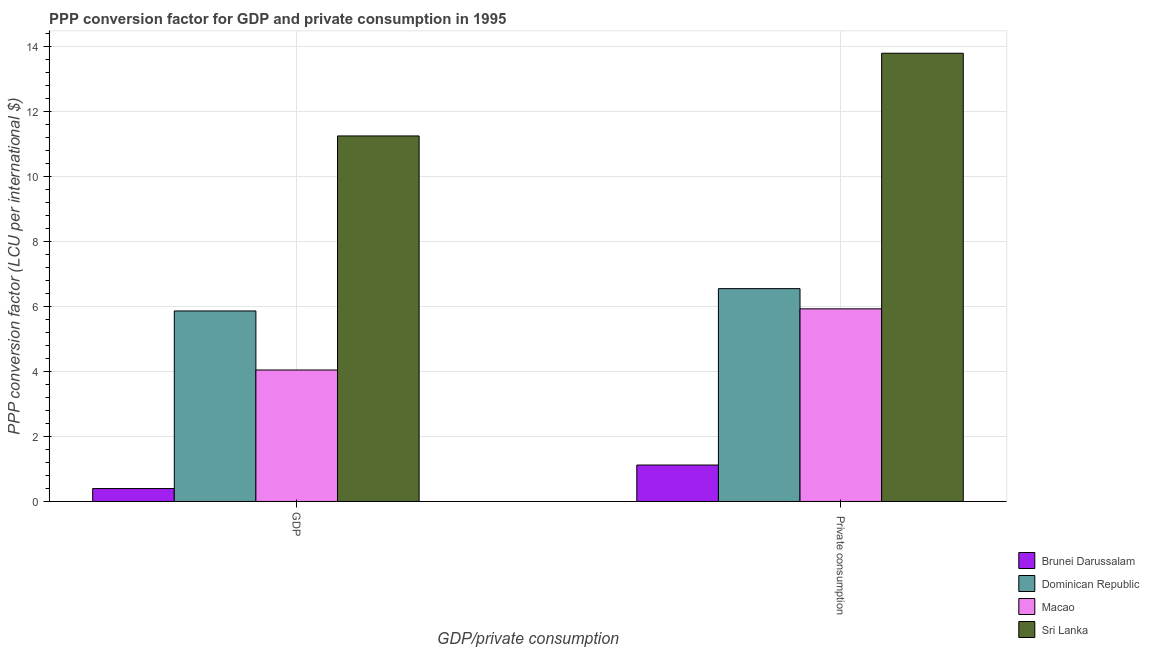How many different coloured bars are there?
Give a very brief answer. 4. How many groups of bars are there?
Your response must be concise. 2. Are the number of bars per tick equal to the number of legend labels?
Ensure brevity in your answer.  Yes. How many bars are there on the 2nd tick from the left?
Keep it short and to the point. 4. How many bars are there on the 1st tick from the right?
Give a very brief answer. 4. What is the label of the 2nd group of bars from the left?
Provide a succinct answer.  Private consumption. What is the ppp conversion factor for private consumption in Macao?
Offer a very short reply. 5.93. Across all countries, what is the maximum ppp conversion factor for gdp?
Offer a terse response. 11.25. Across all countries, what is the minimum ppp conversion factor for private consumption?
Keep it short and to the point. 1.12. In which country was the ppp conversion factor for gdp maximum?
Provide a succinct answer. Sri Lanka. In which country was the ppp conversion factor for private consumption minimum?
Ensure brevity in your answer.  Brunei Darussalam. What is the total ppp conversion factor for gdp in the graph?
Provide a succinct answer. 21.56. What is the difference between the ppp conversion factor for private consumption in Sri Lanka and that in Dominican Republic?
Provide a succinct answer. 7.24. What is the difference between the ppp conversion factor for gdp in Macao and the ppp conversion factor for private consumption in Dominican Republic?
Provide a short and direct response. -2.5. What is the average ppp conversion factor for private consumption per country?
Give a very brief answer. 6.85. What is the difference between the ppp conversion factor for private consumption and ppp conversion factor for gdp in Macao?
Your response must be concise. 1.88. In how many countries, is the ppp conversion factor for gdp greater than 8.4 LCU?
Keep it short and to the point. 1. What is the ratio of the ppp conversion factor for private consumption in Sri Lanka to that in Macao?
Ensure brevity in your answer.  2.33. What does the 1st bar from the left in GDP represents?
Offer a terse response. Brunei Darussalam. What does the 4th bar from the right in  Private consumption represents?
Your answer should be compact. Brunei Darussalam. How many bars are there?
Your answer should be compact. 8. How many countries are there in the graph?
Your response must be concise. 4. How many legend labels are there?
Give a very brief answer. 4. How are the legend labels stacked?
Make the answer very short. Vertical. What is the title of the graph?
Your response must be concise. PPP conversion factor for GDP and private consumption in 1995. What is the label or title of the X-axis?
Offer a terse response. GDP/private consumption. What is the label or title of the Y-axis?
Your answer should be compact. PPP conversion factor (LCU per international $). What is the PPP conversion factor (LCU per international $) in Brunei Darussalam in GDP?
Offer a very short reply. 0.4. What is the PPP conversion factor (LCU per international $) in Dominican Republic in GDP?
Your answer should be very brief. 5.86. What is the PPP conversion factor (LCU per international $) of Macao in GDP?
Make the answer very short. 4.05. What is the PPP conversion factor (LCU per international $) of Sri Lanka in GDP?
Provide a short and direct response. 11.25. What is the PPP conversion factor (LCU per international $) in Brunei Darussalam in  Private consumption?
Offer a very short reply. 1.12. What is the PPP conversion factor (LCU per international $) of Dominican Republic in  Private consumption?
Provide a succinct answer. 6.55. What is the PPP conversion factor (LCU per international $) in Macao in  Private consumption?
Provide a short and direct response. 5.93. What is the PPP conversion factor (LCU per international $) of Sri Lanka in  Private consumption?
Offer a terse response. 13.79. Across all GDP/private consumption, what is the maximum PPP conversion factor (LCU per international $) of Brunei Darussalam?
Provide a succinct answer. 1.12. Across all GDP/private consumption, what is the maximum PPP conversion factor (LCU per international $) of Dominican Republic?
Keep it short and to the point. 6.55. Across all GDP/private consumption, what is the maximum PPP conversion factor (LCU per international $) of Macao?
Keep it short and to the point. 5.93. Across all GDP/private consumption, what is the maximum PPP conversion factor (LCU per international $) of Sri Lanka?
Ensure brevity in your answer.  13.79. Across all GDP/private consumption, what is the minimum PPP conversion factor (LCU per international $) in Brunei Darussalam?
Your answer should be very brief. 0.4. Across all GDP/private consumption, what is the minimum PPP conversion factor (LCU per international $) of Dominican Republic?
Offer a very short reply. 5.86. Across all GDP/private consumption, what is the minimum PPP conversion factor (LCU per international $) in Macao?
Provide a succinct answer. 4.05. Across all GDP/private consumption, what is the minimum PPP conversion factor (LCU per international $) in Sri Lanka?
Your response must be concise. 11.25. What is the total PPP conversion factor (LCU per international $) of Brunei Darussalam in the graph?
Make the answer very short. 1.52. What is the total PPP conversion factor (LCU per international $) of Dominican Republic in the graph?
Ensure brevity in your answer.  12.41. What is the total PPP conversion factor (LCU per international $) in Macao in the graph?
Provide a succinct answer. 9.98. What is the total PPP conversion factor (LCU per international $) of Sri Lanka in the graph?
Offer a terse response. 25.04. What is the difference between the PPP conversion factor (LCU per international $) in Brunei Darussalam in GDP and that in  Private consumption?
Ensure brevity in your answer.  -0.72. What is the difference between the PPP conversion factor (LCU per international $) of Dominican Republic in GDP and that in  Private consumption?
Provide a short and direct response. -0.69. What is the difference between the PPP conversion factor (LCU per international $) in Macao in GDP and that in  Private consumption?
Provide a succinct answer. -1.88. What is the difference between the PPP conversion factor (LCU per international $) of Sri Lanka in GDP and that in  Private consumption?
Your answer should be compact. -2.55. What is the difference between the PPP conversion factor (LCU per international $) of Brunei Darussalam in GDP and the PPP conversion factor (LCU per international $) of Dominican Republic in  Private consumption?
Provide a succinct answer. -6.15. What is the difference between the PPP conversion factor (LCU per international $) in Brunei Darussalam in GDP and the PPP conversion factor (LCU per international $) in Macao in  Private consumption?
Your answer should be very brief. -5.53. What is the difference between the PPP conversion factor (LCU per international $) of Brunei Darussalam in GDP and the PPP conversion factor (LCU per international $) of Sri Lanka in  Private consumption?
Keep it short and to the point. -13.4. What is the difference between the PPP conversion factor (LCU per international $) of Dominican Republic in GDP and the PPP conversion factor (LCU per international $) of Macao in  Private consumption?
Give a very brief answer. -0.07. What is the difference between the PPP conversion factor (LCU per international $) of Dominican Republic in GDP and the PPP conversion factor (LCU per international $) of Sri Lanka in  Private consumption?
Keep it short and to the point. -7.93. What is the difference between the PPP conversion factor (LCU per international $) of Macao in GDP and the PPP conversion factor (LCU per international $) of Sri Lanka in  Private consumption?
Your answer should be very brief. -9.75. What is the average PPP conversion factor (LCU per international $) of Brunei Darussalam per GDP/private consumption?
Ensure brevity in your answer.  0.76. What is the average PPP conversion factor (LCU per international $) in Dominican Republic per GDP/private consumption?
Offer a very short reply. 6.21. What is the average PPP conversion factor (LCU per international $) in Macao per GDP/private consumption?
Your response must be concise. 4.99. What is the average PPP conversion factor (LCU per international $) in Sri Lanka per GDP/private consumption?
Provide a short and direct response. 12.52. What is the difference between the PPP conversion factor (LCU per international $) of Brunei Darussalam and PPP conversion factor (LCU per international $) of Dominican Republic in GDP?
Ensure brevity in your answer.  -5.47. What is the difference between the PPP conversion factor (LCU per international $) in Brunei Darussalam and PPP conversion factor (LCU per international $) in Macao in GDP?
Make the answer very short. -3.65. What is the difference between the PPP conversion factor (LCU per international $) of Brunei Darussalam and PPP conversion factor (LCU per international $) of Sri Lanka in GDP?
Provide a succinct answer. -10.85. What is the difference between the PPP conversion factor (LCU per international $) of Dominican Republic and PPP conversion factor (LCU per international $) of Macao in GDP?
Offer a terse response. 1.82. What is the difference between the PPP conversion factor (LCU per international $) in Dominican Republic and PPP conversion factor (LCU per international $) in Sri Lanka in GDP?
Ensure brevity in your answer.  -5.39. What is the difference between the PPP conversion factor (LCU per international $) in Macao and PPP conversion factor (LCU per international $) in Sri Lanka in GDP?
Keep it short and to the point. -7.2. What is the difference between the PPP conversion factor (LCU per international $) in Brunei Darussalam and PPP conversion factor (LCU per international $) in Dominican Republic in  Private consumption?
Your answer should be compact. -5.43. What is the difference between the PPP conversion factor (LCU per international $) in Brunei Darussalam and PPP conversion factor (LCU per international $) in Macao in  Private consumption?
Your answer should be compact. -4.81. What is the difference between the PPP conversion factor (LCU per international $) in Brunei Darussalam and PPP conversion factor (LCU per international $) in Sri Lanka in  Private consumption?
Provide a short and direct response. -12.67. What is the difference between the PPP conversion factor (LCU per international $) in Dominican Republic and PPP conversion factor (LCU per international $) in Macao in  Private consumption?
Your answer should be very brief. 0.62. What is the difference between the PPP conversion factor (LCU per international $) of Dominican Republic and PPP conversion factor (LCU per international $) of Sri Lanka in  Private consumption?
Give a very brief answer. -7.24. What is the difference between the PPP conversion factor (LCU per international $) of Macao and PPP conversion factor (LCU per international $) of Sri Lanka in  Private consumption?
Provide a succinct answer. -7.87. What is the ratio of the PPP conversion factor (LCU per international $) in Brunei Darussalam in GDP to that in  Private consumption?
Provide a succinct answer. 0.35. What is the ratio of the PPP conversion factor (LCU per international $) in Dominican Republic in GDP to that in  Private consumption?
Your answer should be very brief. 0.9. What is the ratio of the PPP conversion factor (LCU per international $) in Macao in GDP to that in  Private consumption?
Provide a succinct answer. 0.68. What is the ratio of the PPP conversion factor (LCU per international $) of Sri Lanka in GDP to that in  Private consumption?
Make the answer very short. 0.82. What is the difference between the highest and the second highest PPP conversion factor (LCU per international $) of Brunei Darussalam?
Make the answer very short. 0.72. What is the difference between the highest and the second highest PPP conversion factor (LCU per international $) of Dominican Republic?
Provide a short and direct response. 0.69. What is the difference between the highest and the second highest PPP conversion factor (LCU per international $) in Macao?
Offer a terse response. 1.88. What is the difference between the highest and the second highest PPP conversion factor (LCU per international $) in Sri Lanka?
Your answer should be compact. 2.55. What is the difference between the highest and the lowest PPP conversion factor (LCU per international $) of Brunei Darussalam?
Provide a succinct answer. 0.72. What is the difference between the highest and the lowest PPP conversion factor (LCU per international $) in Dominican Republic?
Your answer should be compact. 0.69. What is the difference between the highest and the lowest PPP conversion factor (LCU per international $) in Macao?
Your answer should be compact. 1.88. What is the difference between the highest and the lowest PPP conversion factor (LCU per international $) of Sri Lanka?
Offer a terse response. 2.55. 